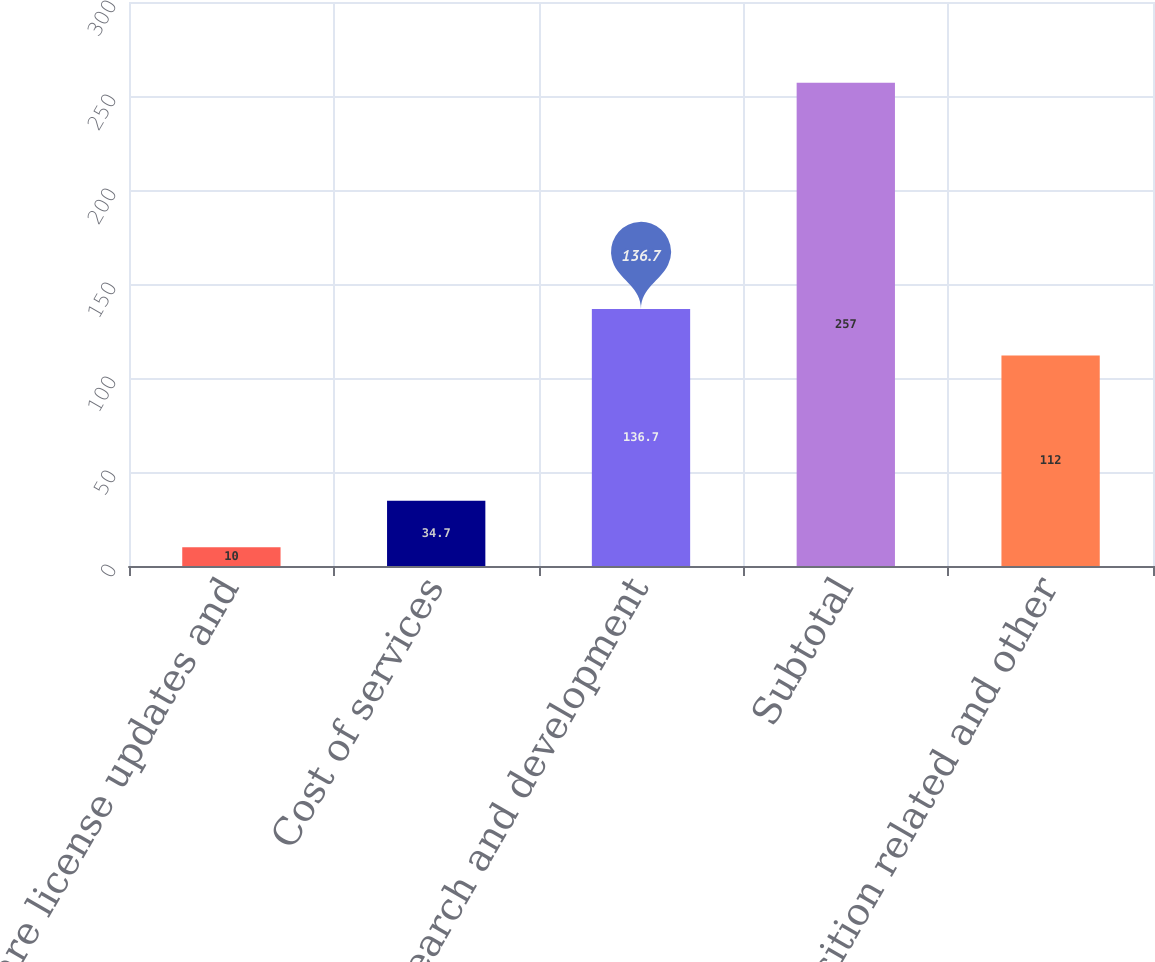Convert chart. <chart><loc_0><loc_0><loc_500><loc_500><bar_chart><fcel>Software license updates and<fcel>Cost of services<fcel>Research and development<fcel>Subtotal<fcel>Acquisition related and other<nl><fcel>10<fcel>34.7<fcel>136.7<fcel>257<fcel>112<nl></chart> 